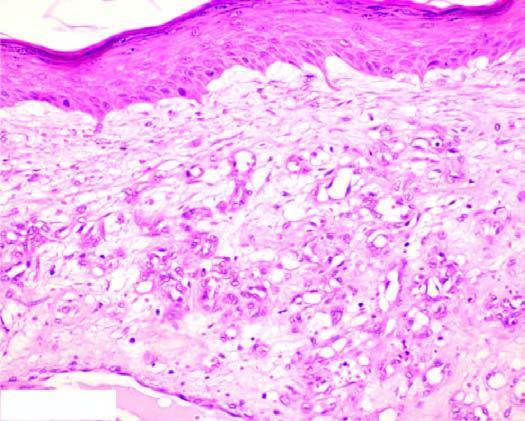does the intervening stroma consist of scant connective tissue?
Answer the question using a single word or phrase. Yes 